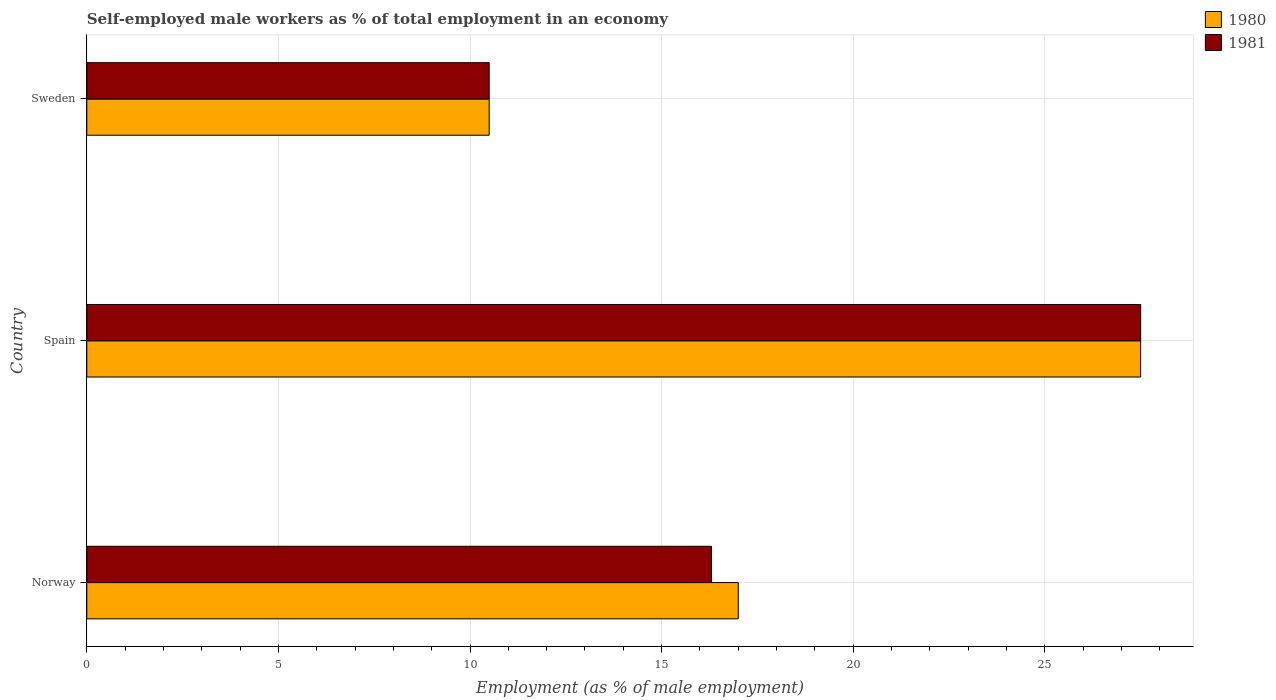Are the number of bars per tick equal to the number of legend labels?
Make the answer very short. Yes. Are the number of bars on each tick of the Y-axis equal?
Offer a very short reply. Yes. In how many cases, is the number of bars for a given country not equal to the number of legend labels?
Your response must be concise. 0. What is the percentage of self-employed male workers in 1980 in Spain?
Offer a terse response. 27.5. Across all countries, what is the maximum percentage of self-employed male workers in 1980?
Your answer should be compact. 27.5. In which country was the percentage of self-employed male workers in 1981 minimum?
Offer a terse response. Sweden. What is the difference between the percentage of self-employed male workers in 1981 in Norway and the percentage of self-employed male workers in 1980 in Sweden?
Offer a very short reply. 5.8. What is the average percentage of self-employed male workers in 1980 per country?
Keep it short and to the point. 18.33. What is the ratio of the percentage of self-employed male workers in 1980 in Norway to that in Spain?
Give a very brief answer. 0.62. Is the percentage of self-employed male workers in 1981 in Norway less than that in Sweden?
Make the answer very short. No. What is the difference between the highest and the second highest percentage of self-employed male workers in 1981?
Provide a succinct answer. 11.2. What is the difference between the highest and the lowest percentage of self-employed male workers in 1981?
Your answer should be very brief. 17. How many bars are there?
Your answer should be very brief. 6. Are all the bars in the graph horizontal?
Ensure brevity in your answer.  Yes. How many countries are there in the graph?
Provide a short and direct response. 3. What is the difference between two consecutive major ticks on the X-axis?
Your answer should be compact. 5. Does the graph contain grids?
Offer a terse response. Yes. Where does the legend appear in the graph?
Offer a very short reply. Top right. How many legend labels are there?
Your answer should be very brief. 2. What is the title of the graph?
Provide a short and direct response. Self-employed male workers as % of total employment in an economy. What is the label or title of the X-axis?
Provide a succinct answer. Employment (as % of male employment). What is the label or title of the Y-axis?
Provide a short and direct response. Country. What is the Employment (as % of male employment) in 1980 in Norway?
Provide a succinct answer. 17. What is the Employment (as % of male employment) of 1981 in Norway?
Offer a terse response. 16.3. What is the Employment (as % of male employment) of 1981 in Spain?
Give a very brief answer. 27.5. Across all countries, what is the maximum Employment (as % of male employment) of 1980?
Provide a short and direct response. 27.5. Across all countries, what is the minimum Employment (as % of male employment) of 1980?
Your answer should be compact. 10.5. Across all countries, what is the minimum Employment (as % of male employment) in 1981?
Provide a short and direct response. 10.5. What is the total Employment (as % of male employment) of 1980 in the graph?
Your response must be concise. 55. What is the total Employment (as % of male employment) of 1981 in the graph?
Ensure brevity in your answer.  54.3. What is the difference between the Employment (as % of male employment) in 1980 in Norway and that in Spain?
Keep it short and to the point. -10.5. What is the difference between the Employment (as % of male employment) in 1980 in Spain and that in Sweden?
Your answer should be compact. 17. What is the difference between the Employment (as % of male employment) in 1981 in Spain and that in Sweden?
Offer a terse response. 17. What is the difference between the Employment (as % of male employment) of 1980 in Norway and the Employment (as % of male employment) of 1981 in Spain?
Your response must be concise. -10.5. What is the difference between the Employment (as % of male employment) in 1980 in Norway and the Employment (as % of male employment) in 1981 in Sweden?
Your response must be concise. 6.5. What is the average Employment (as % of male employment) of 1980 per country?
Your answer should be very brief. 18.33. What is the average Employment (as % of male employment) in 1981 per country?
Give a very brief answer. 18.1. What is the difference between the Employment (as % of male employment) in 1980 and Employment (as % of male employment) in 1981 in Norway?
Offer a very short reply. 0.7. What is the difference between the Employment (as % of male employment) of 1980 and Employment (as % of male employment) of 1981 in Spain?
Give a very brief answer. 0. What is the ratio of the Employment (as % of male employment) in 1980 in Norway to that in Spain?
Provide a short and direct response. 0.62. What is the ratio of the Employment (as % of male employment) in 1981 in Norway to that in Spain?
Make the answer very short. 0.59. What is the ratio of the Employment (as % of male employment) in 1980 in Norway to that in Sweden?
Offer a very short reply. 1.62. What is the ratio of the Employment (as % of male employment) in 1981 in Norway to that in Sweden?
Your answer should be compact. 1.55. What is the ratio of the Employment (as % of male employment) of 1980 in Spain to that in Sweden?
Make the answer very short. 2.62. What is the ratio of the Employment (as % of male employment) in 1981 in Spain to that in Sweden?
Provide a succinct answer. 2.62. 